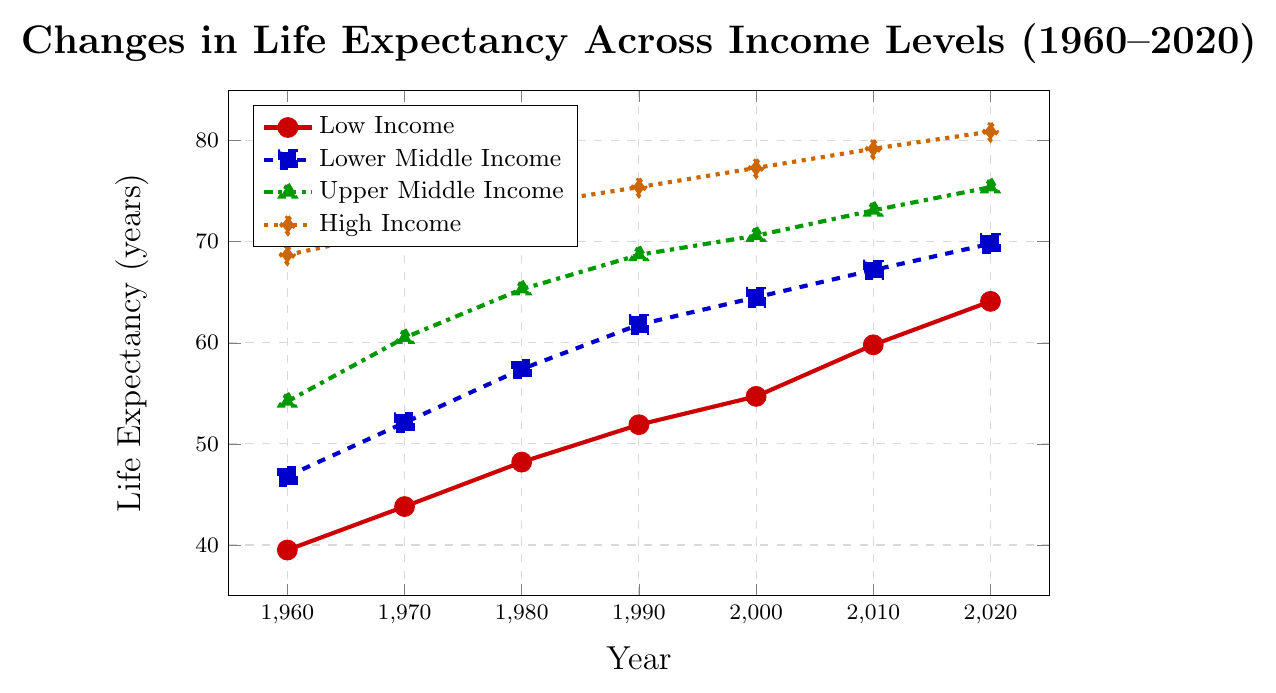What is the life expectancy difference between High Income and Low Income in 1960? In 1960, the life expectancy for High Income was 68.7 years and for Low Income was 39.5 years. The difference is calculated as 68.7 - 39.5.
Answer: 29.2 years Which income level had the highest increase in life expectancy from 1960 to 2020? For each income level, subtract the 1960 life expectancy value from the 2020 value. The differences are: Low Income (64.1 - 39.5 = 24.6), Lower Middle Income (69.8 - 46.8 = 23.0), Upper Middle Income (75.4 - 54.2 = 21.2), and High Income (80.9 - 68.7 = 12.2). The highest increase is for Low Income with a difference of 24.6 years.
Answer: Low Income By how many years did the life expectancy in Lower Middle Income countries increase from 2000 to 2020? In 2000, the life expectancy for Lower Middle Income was 64.5 years. In 2020, it was 69.8 years. The difference is calculated as 69.8 - 64.5.
Answer: 5.3 years Which income group showed the least improvement in life expectancy between 1960 and 2020? The differences in life expectancy from 1960 to 2020 are calculated for each income group, the results being: Low Income (24.6), Lower Middle Income (23.0), Upper Middle Income (21.2), and High Income (12.2). The least improvement is seen in the High Income group.
Answer: High Income What is the average life expectancy for Upper Middle Income countries across all the years shown? Sum the life expectancy values for Upper Middle Income from all the years and divide by the number of years. The values are 54.2, 60.5, 65.3, 68.7, 70.6, 73.1, and 75.4. The sum is 468.8. Divided by 7 years, the average is 468.8/7.
Answer: 67.0 years In which year did Low Income countries surpass a life expectancy of 50 years? Looking at the life expectancy values for Low Income countries over the years: 1960 (39.5), 1970 (43.8), 1980 (48.2), 1990 (51.9). In 1990, the life expectancy surpasses 50 years.
Answer: 1990 Between 1980 and 2000, which income group experienced the largest change in life expectancy? Calculate the difference between 1980 and 2000 for each income group: Low Income (54.7 - 48.2 = 6.5), Lower Middle Income (64.5 - 57.4 = 7.1), Upper Middle Income (70.6 - 65.3 = 5.3), High Income (77.3 - 73.6 = 3.7). The largest change is seen in the Lower Middle Income group with a difference of 7.1 years.
Answer: Lower Middle Income How did the gap in life expectancy between Upper Middle Income and Lower Middle Income countries change from 1960 to 2020? In 1960, the gap is 54.2 - 46.8 = 7.4 years. In 2020, the gap is 75.4 - 69.8 = 5.6 years. The change in the gap is calculated as 7.4 - 5.6.
Answer: -1.8 years Which income group had the smallest increase in life expectancy from 1980 to 1990? Calculate the differences between 1980 and 1990 for each income group: Low Income (51.9 - 48.2 = 3.7), Lower Middle Income (61.8 - 57.4 = 4.4), Upper Middle Income (68.7 - 65.3 = 3.4), High Income (75.4 - 73.6 = 1.8). The smallest increase is seen in the High Income group.
Answer: High Income 